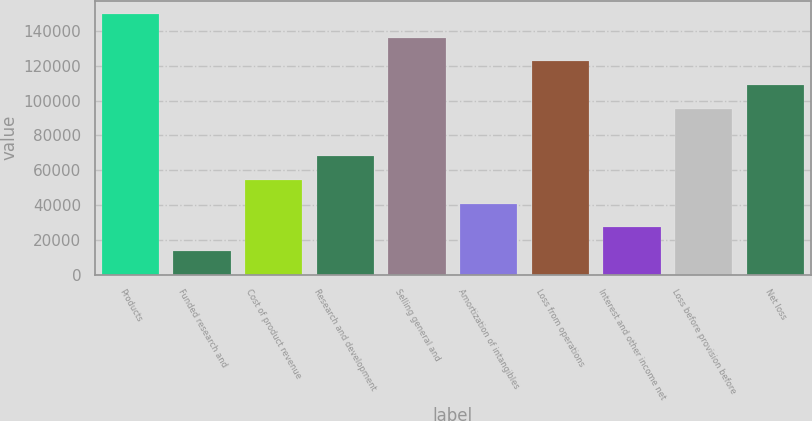Convert chart. <chart><loc_0><loc_0><loc_500><loc_500><bar_chart><fcel>Products<fcel>Funded research and<fcel>Cost of product revenue<fcel>Research and development<fcel>Selling general and<fcel>Amortization of intangibles<fcel>Loss from operations<fcel>Interest and other income net<fcel>Loss before provision before<fcel>Net loss<nl><fcel>149801<fcel>13619.2<fcel>54473.8<fcel>68092<fcel>136183<fcel>40855.6<fcel>122565<fcel>27237.4<fcel>95328.4<fcel>108947<nl></chart> 